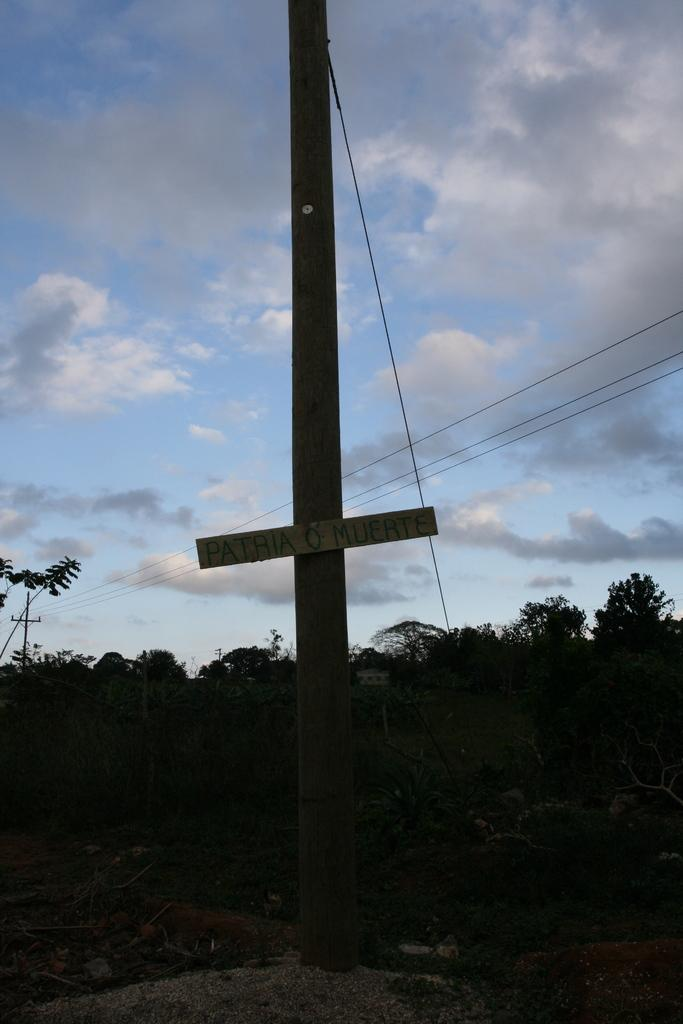What is the condition of the sky in the image? The sky is cloudy in the image. What type of vegetation can be seen in the background? There are trees in the background. What structure is present in the image? There is a board on a pole in the image. Can you see any zebras drinking water from the hole in the image? There are no zebras or holes with water present in the image. 